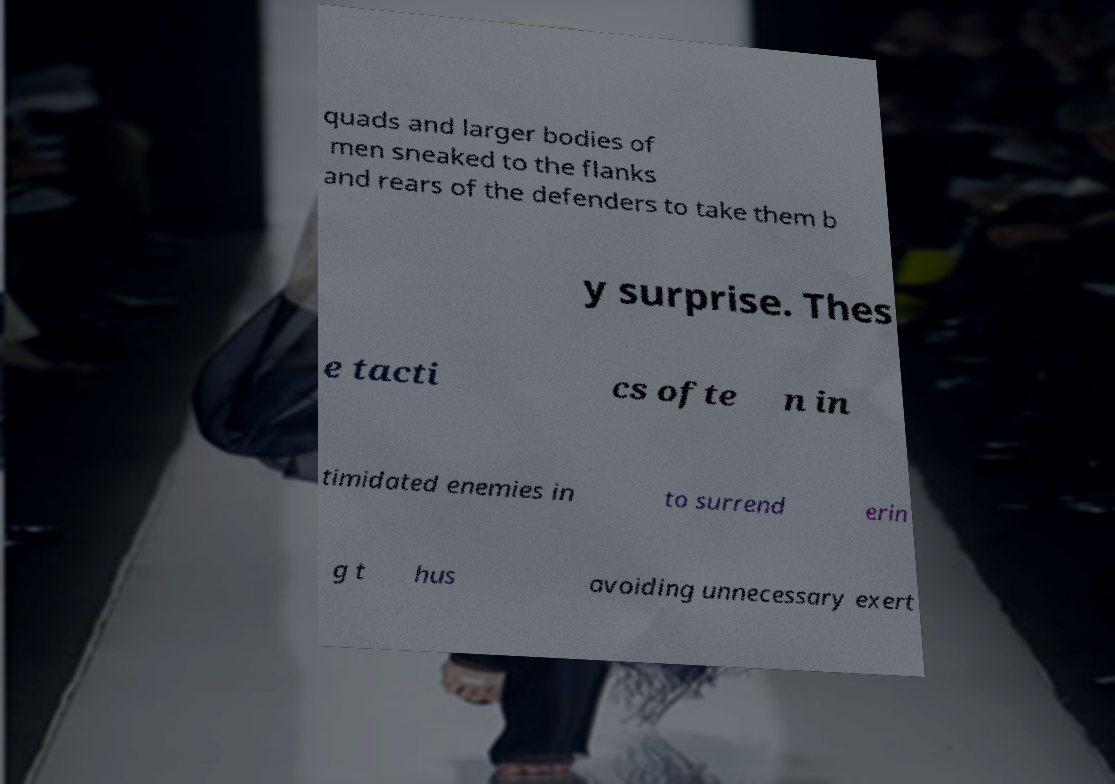There's text embedded in this image that I need extracted. Can you transcribe it verbatim? quads and larger bodies of men sneaked to the flanks and rears of the defenders to take them b y surprise. Thes e tacti cs ofte n in timidated enemies in to surrend erin g t hus avoiding unnecessary exert 